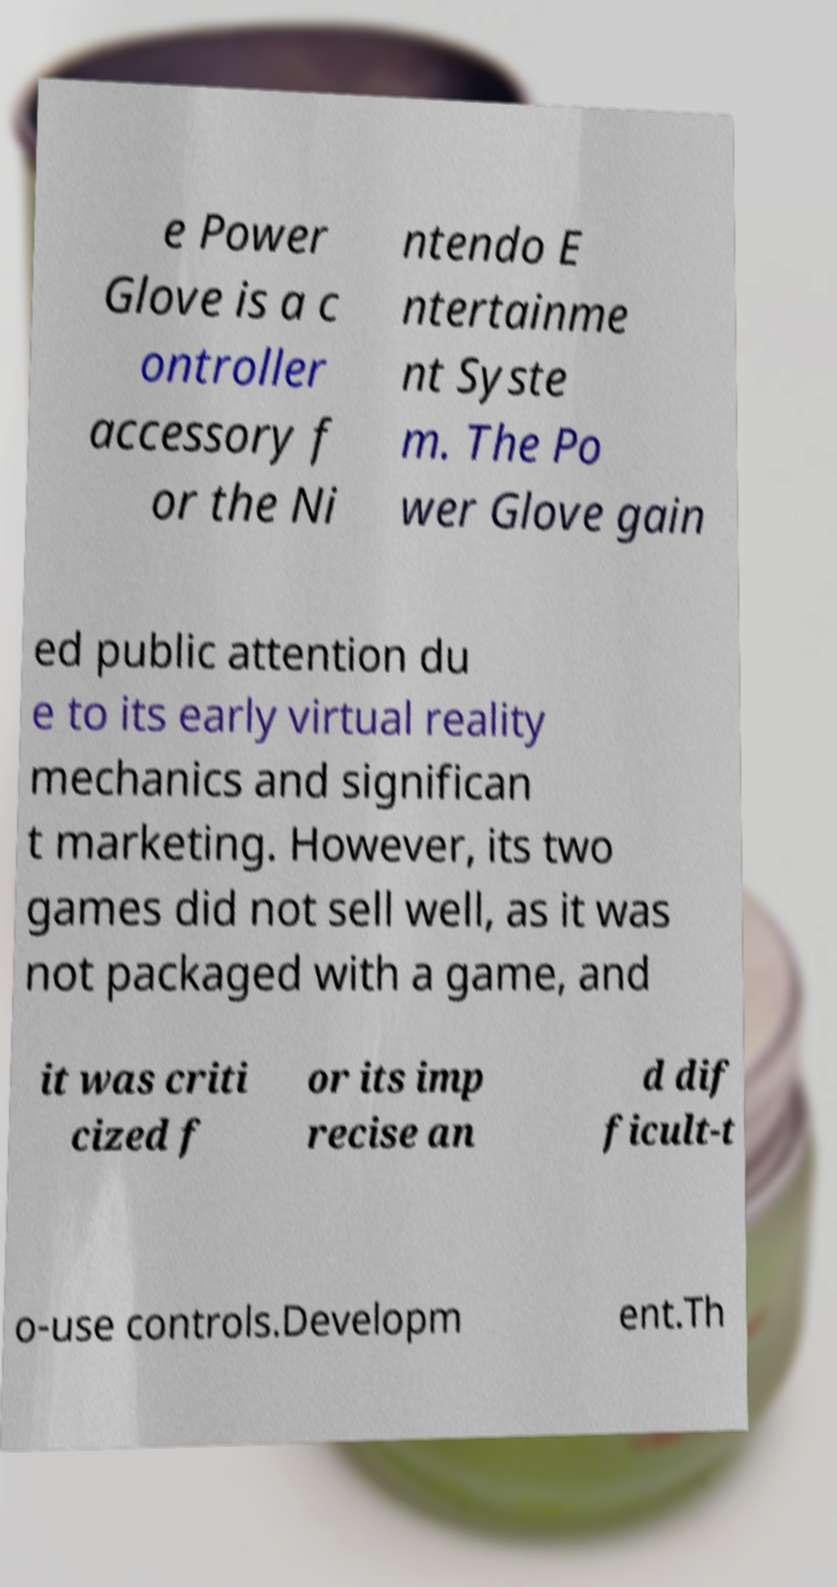Can you read and provide the text displayed in the image?This photo seems to have some interesting text. Can you extract and type it out for me? e Power Glove is a c ontroller accessory f or the Ni ntendo E ntertainme nt Syste m. The Po wer Glove gain ed public attention du e to its early virtual reality mechanics and significan t marketing. However, its two games did not sell well, as it was not packaged with a game, and it was criti cized f or its imp recise an d dif ficult-t o-use controls.Developm ent.Th 